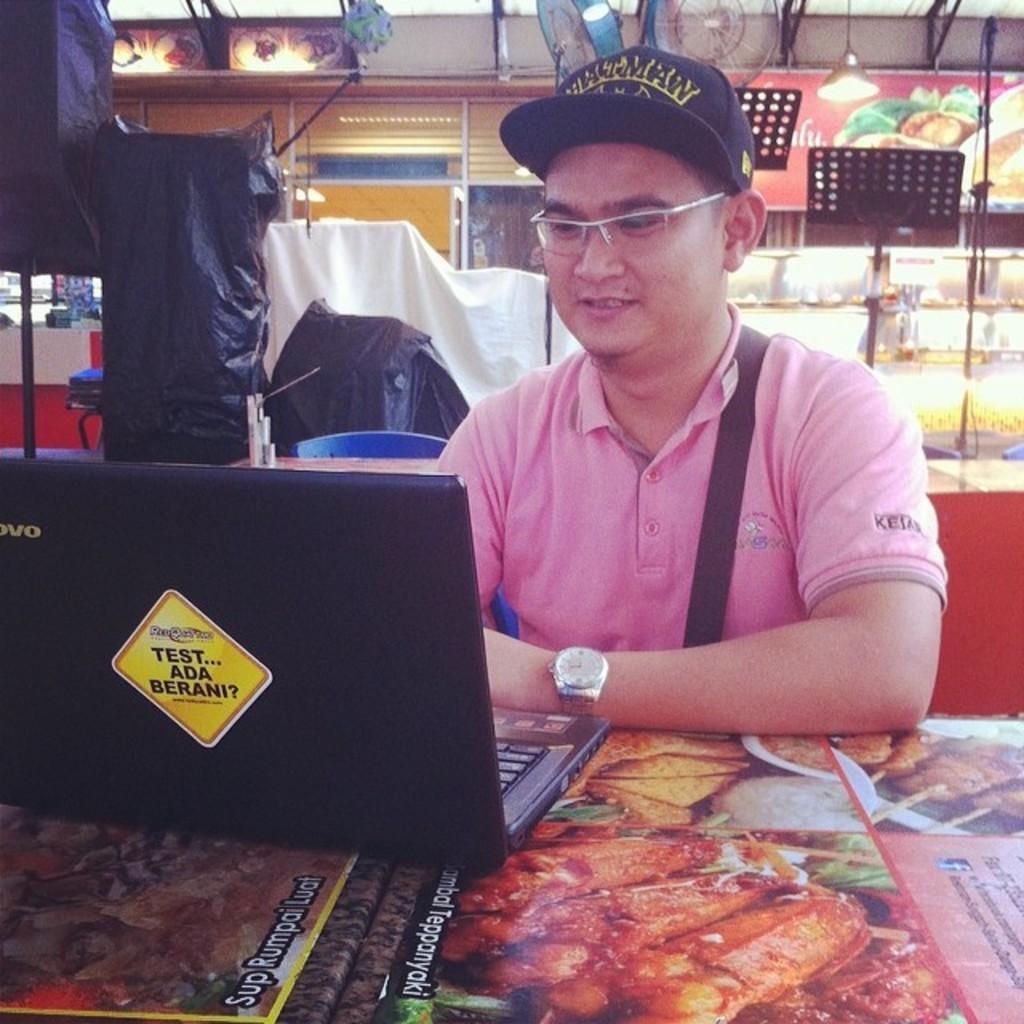Who is present in the image? There is a man in the image. What accessories is the man wearing? The man is wearing spectacles and a watch. What type of clothing is the man wearing? The man is wearing a t-shirt. What electronic device can be seen in the image? There is a black color laptop on a table. What can be seen in the background of the image? There are objects visible in the background of the image. What type of arithmetic problem is the man solving on the banana in the image? There is no banana present in the image, and the man is not solving any arithmetic problems. 